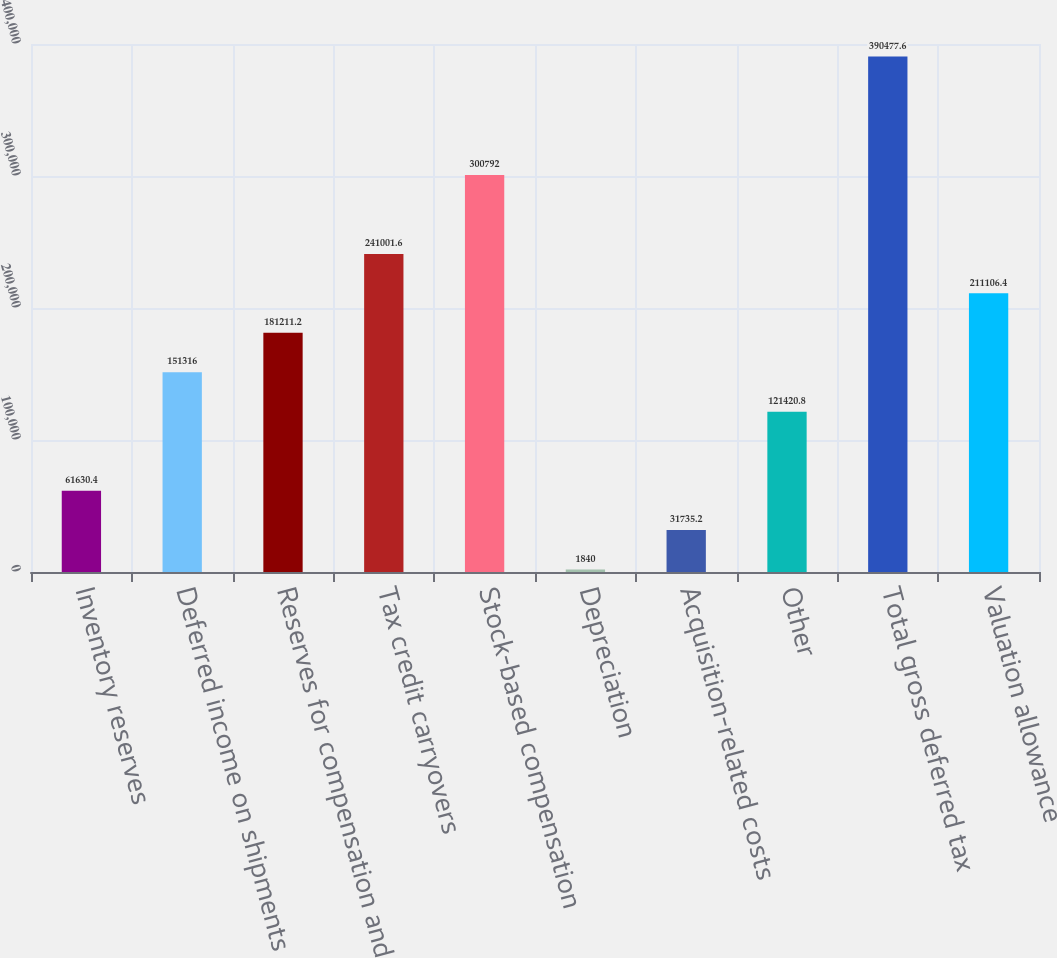<chart> <loc_0><loc_0><loc_500><loc_500><bar_chart><fcel>Inventory reserves<fcel>Deferred income on shipments<fcel>Reserves for compensation and<fcel>Tax credit carryovers<fcel>Stock-based compensation<fcel>Depreciation<fcel>Acquisition-related costs<fcel>Other<fcel>Total gross deferred tax<fcel>Valuation allowance<nl><fcel>61630.4<fcel>151316<fcel>181211<fcel>241002<fcel>300792<fcel>1840<fcel>31735.2<fcel>121421<fcel>390478<fcel>211106<nl></chart> 